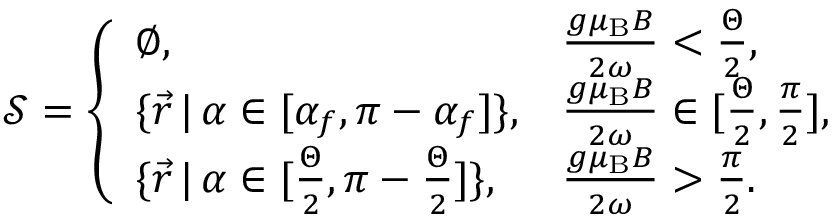<formula> <loc_0><loc_0><loc_500><loc_500>\mathcal { S } = \left \{ \begin{array} { l l } { \emptyset , } & { \frac { g \mu _ { B } B } { 2 \omega } < \frac { \Theta } { 2 } , } \\ { \{ \vec { r } \, | \, \alpha \in [ \alpha _ { f } , \pi - \alpha _ { f } ] \} , } & { \frac { g \mu _ { B } B } { 2 \omega } \in [ \frac { \Theta } { 2 } , \frac { \pi } { 2 } ] , } \\ { \{ \vec { r } \, | \, \alpha \in [ \frac { \Theta } { 2 } , \pi - \frac { \Theta } { 2 } ] \} , } & { \frac { g \mu _ { B } B } { 2 \omega } > \frac { \pi } { 2 } . } \end{array}</formula> 